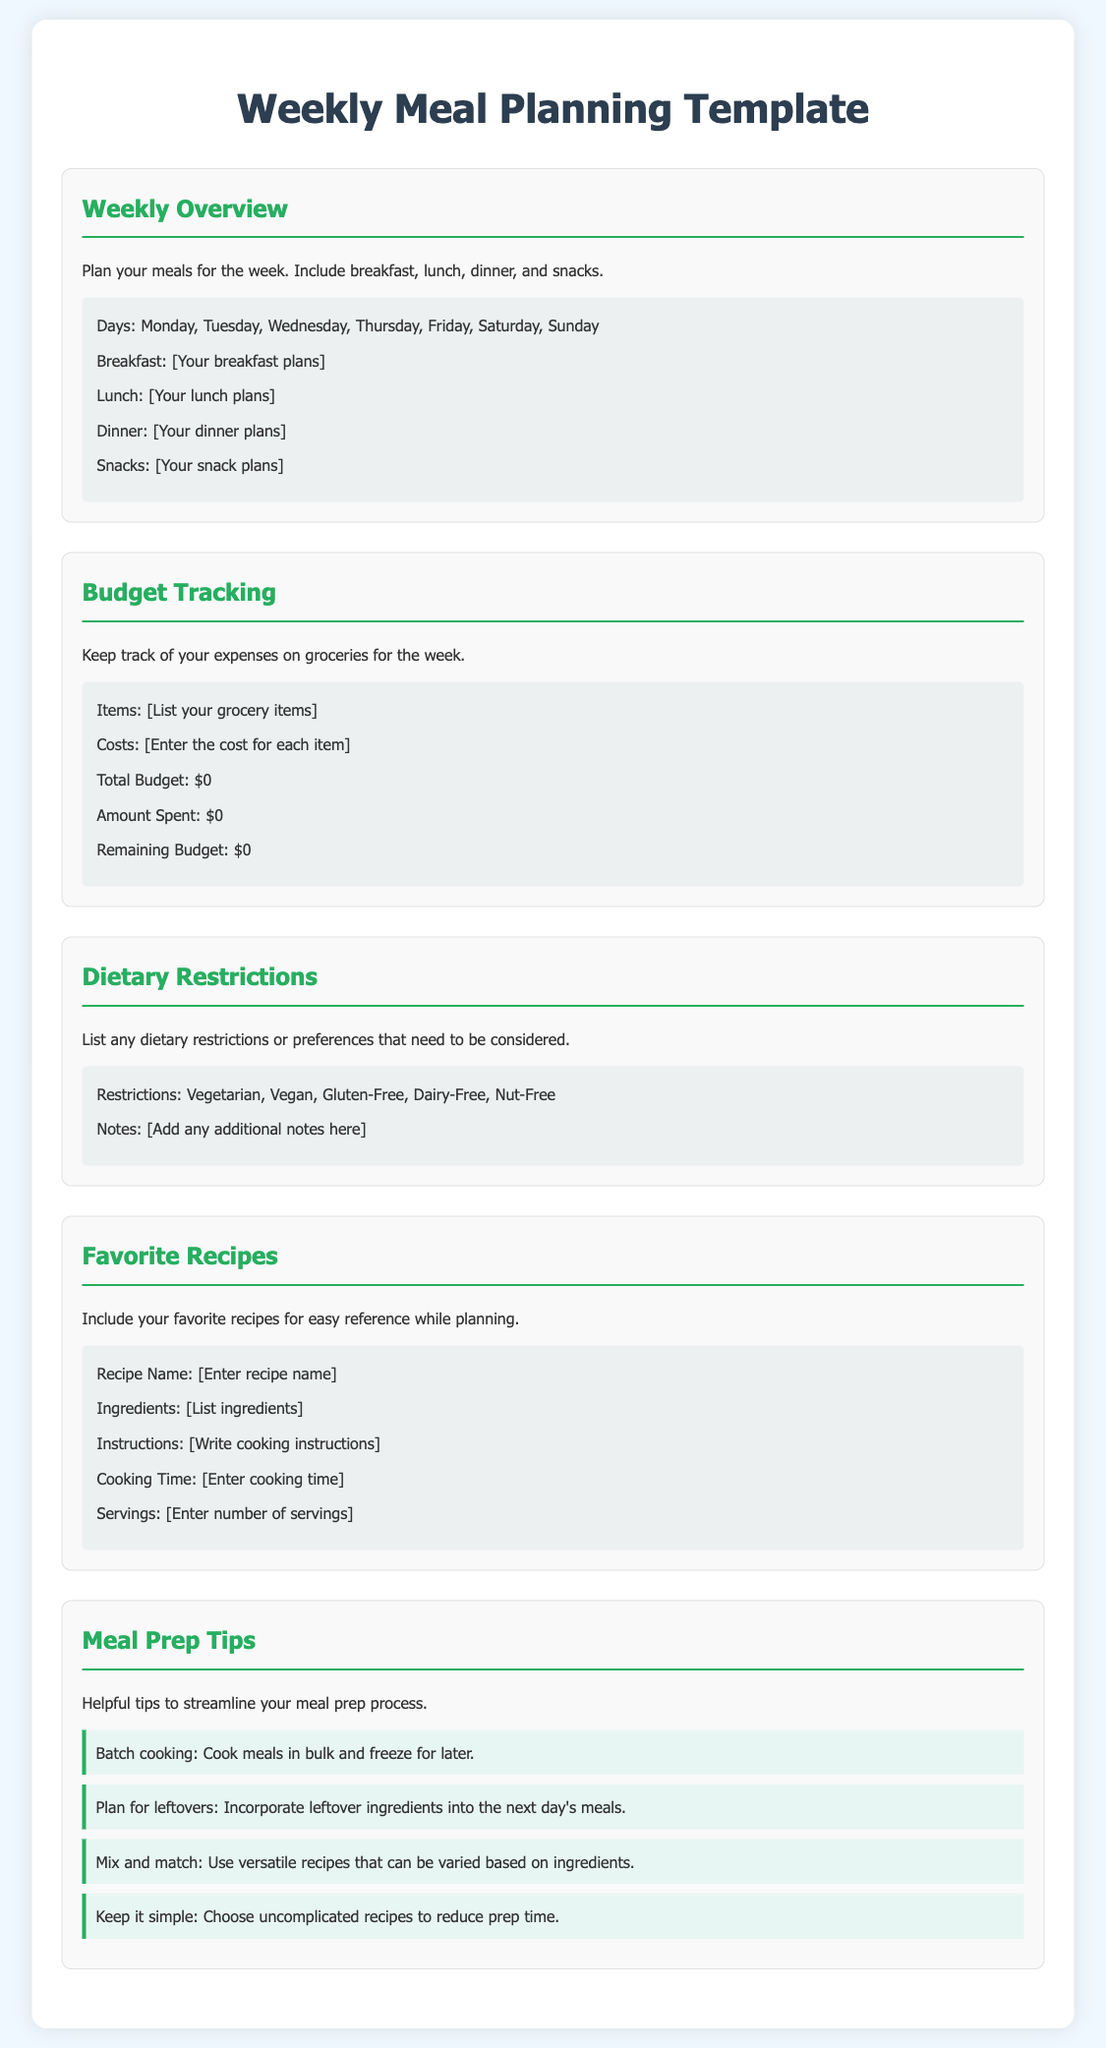what is the title of the document? The title provided in the document is located at the top and sets the main subject of the content.
Answer: Weekly Meal Planning Template how many sections are there in the document? The number of sections is counted from the document's main content, each introduced with a subheading.
Answer: 5 what colors are used for the headings? The headings use a specific color that is consistent throughout the document to maintain a cohesive design.
Answer: #27ae60 what should you list in the Budget Tracking section? This section instructs users on what to keep track of regarding their meal-related expenses for the week.
Answer: grocery items what is the cooking time entry in the Favorite Recipes section? The template specifies a placeholder that prompts the user to provide specific details related to their recipes.
Answer: Enter cooking time which dietary restrictions are mentioned? These restrictions are explicitly listed in the dietary section and highlight common dietary preferences.
Answer: Vegetarian, Vegan, Gluten-Free, Dairy-Free, Nut-Free what are two tips provided in the Meal Prep Tips section? The tips consist of practical advice aimed to simplify and hasten the meal preparation process.
Answer: Batch cooking, Plan for leftovers what do you track in the Budget Tracking section? The document indicates specific financial metrics that help in managing the grocery budget throughout the week.
Answer: Expenses how many types of meals are included in the Weekly Overview? The overview section provides a layout for various meals to ensure complete meal planning for each day.
Answer: 4 